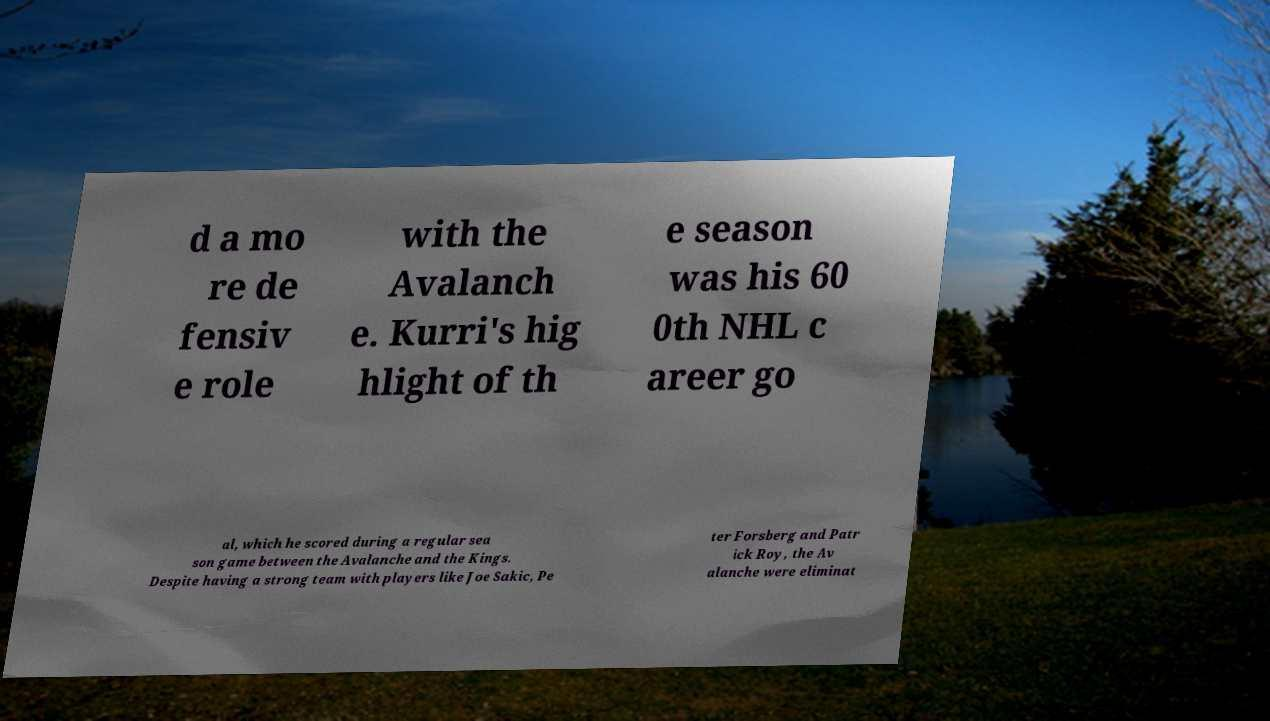Please identify and transcribe the text found in this image. d a mo re de fensiv e role with the Avalanch e. Kurri's hig hlight of th e season was his 60 0th NHL c areer go al, which he scored during a regular sea son game between the Avalanche and the Kings. Despite having a strong team with players like Joe Sakic, Pe ter Forsberg and Patr ick Roy, the Av alanche were eliminat 